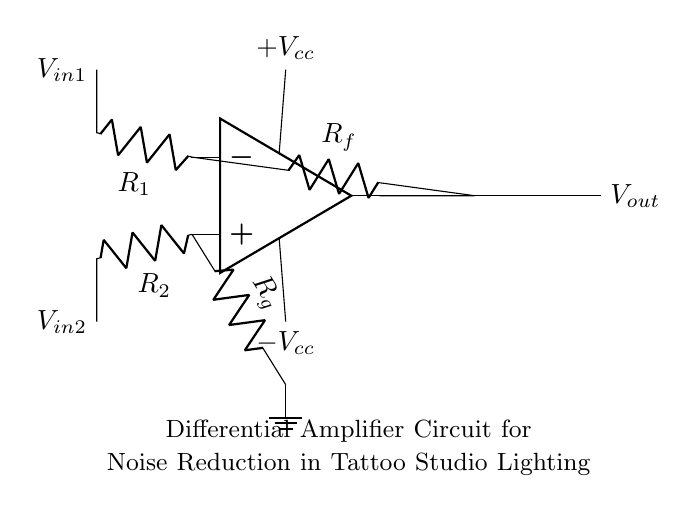What type of circuit is depicted? The circuit is a differential amplifier, characterized by its ability to amplify the difference between two input voltages while rejecting any common noise present in both inputs. The op amp configuration and the arrangement of resistors confirm this.
Answer: differential amplifier What do R1 and R2 represent? R1 and R2 are input resistors connected to the negative and positive input terminals of the op amp, respectively. They determine the input impedance and play a crucial role in setting the gain of the amplifier.
Answer: input resistors What is the function of Rf? Rf is the feedback resistor connected from the output of the op amp to the inverting input. Its main role is to control the overall gain of the amplifier and stabilize its performance.
Answer: feedback resistor What do the positive and negative voltage supplies represent? The positive and negative voltage supplies, labeled as +Vcc and -Vcc, provide the necessary power to the op amp for proper operation. They ensure that the amplifier can operate in both positive and negative output ranges.
Answer: power supply Explain why this circuit is suitable for noise reduction. The differential amplifier is specifically designed to amplify the difference between the two input signals while minimizing any common noise signals that affect both inputs equally. This ability to reject common-mode noise makes it suitable for environments like a tattoo studio with potentially noisy lighting systems.
Answer: common-mode noise rejection What is the output voltage expression of this differential amplifier? The output voltage of a differential amplifier can be expressed as Vout = (Rf/R1) * (Vin1 - Vin2). This formula illustrates how the output voltage is proportional to the difference in input voltages, scaled by the resistor ratios, allowing for controlled amplification.
Answer: Vin1 - Vin2 * (Rf/R1) 